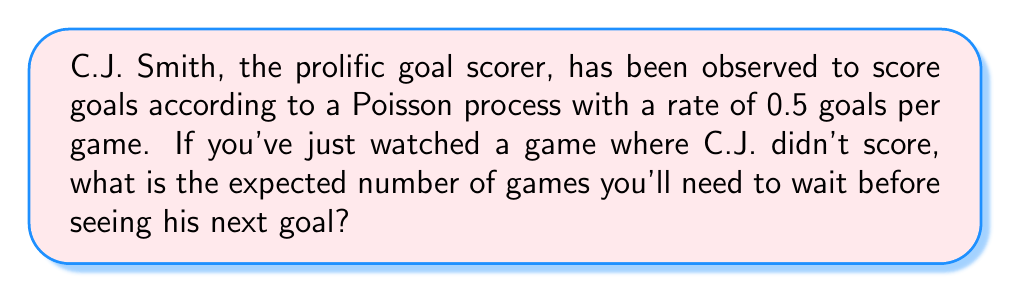Give your solution to this math problem. Let's approach this step-by-step:

1) In a Poisson process, the time between events (in this case, goals) follows an exponential distribution.

2) The rate parameter of the Poisson process, λ, is 0.5 goals per game.

3) For an exponential distribution, the expected value (mean) is given by:

   $$ E[X] = \frac{1}{\lambda} $$

   where X is the random variable representing the waiting time.

4) Substituting our value of λ:

   $$ E[X] = \frac{1}{0.5} = 2 $$

5) Therefore, the expected waiting time is 2 games.

Note: This result is independent of the fact that C.J. didn't score in the game you just watched. This is due to the "memoryless" property of the exponential distribution, which means that the waiting time for the next event is not affected by how long we've already waited.
Answer: 2 games 